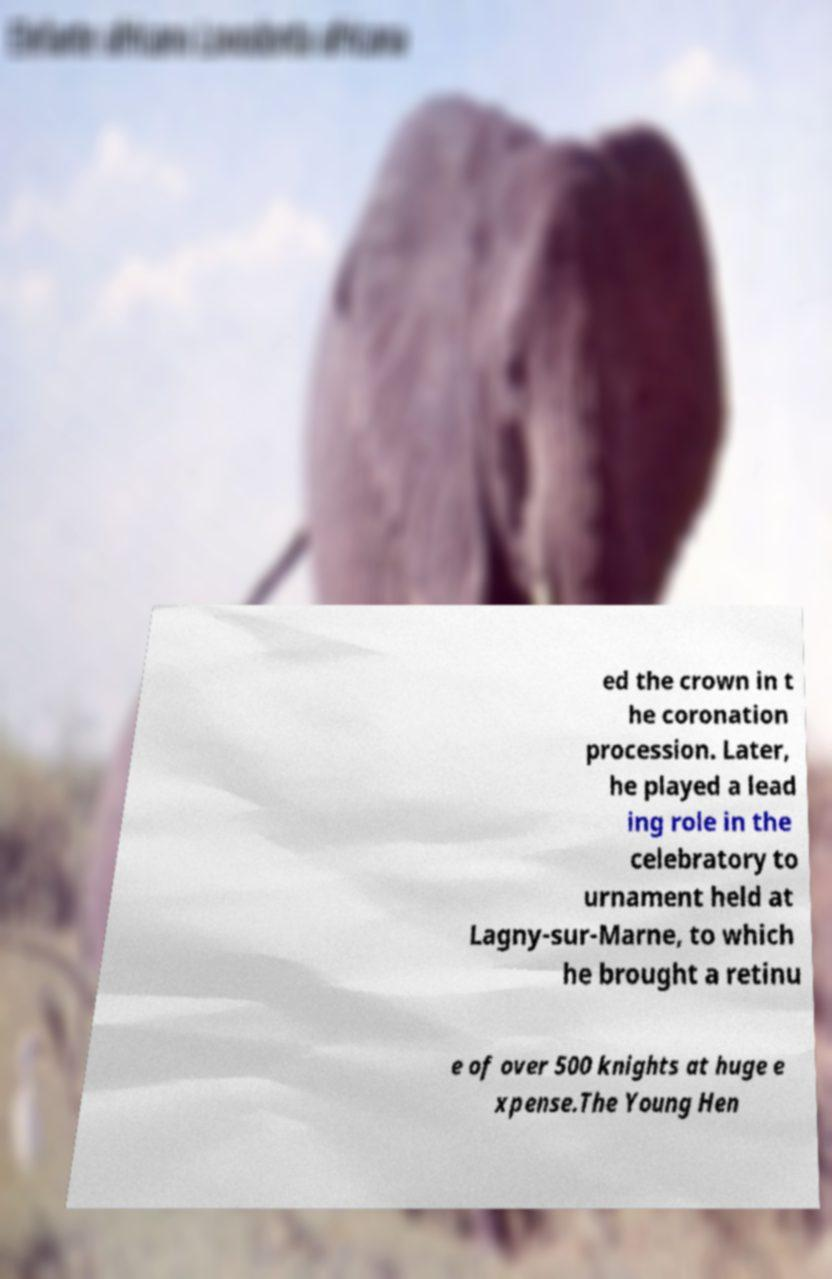There's text embedded in this image that I need extracted. Can you transcribe it verbatim? ed the crown in t he coronation procession. Later, he played a lead ing role in the celebratory to urnament held at Lagny-sur-Marne, to which he brought a retinu e of over 500 knights at huge e xpense.The Young Hen 